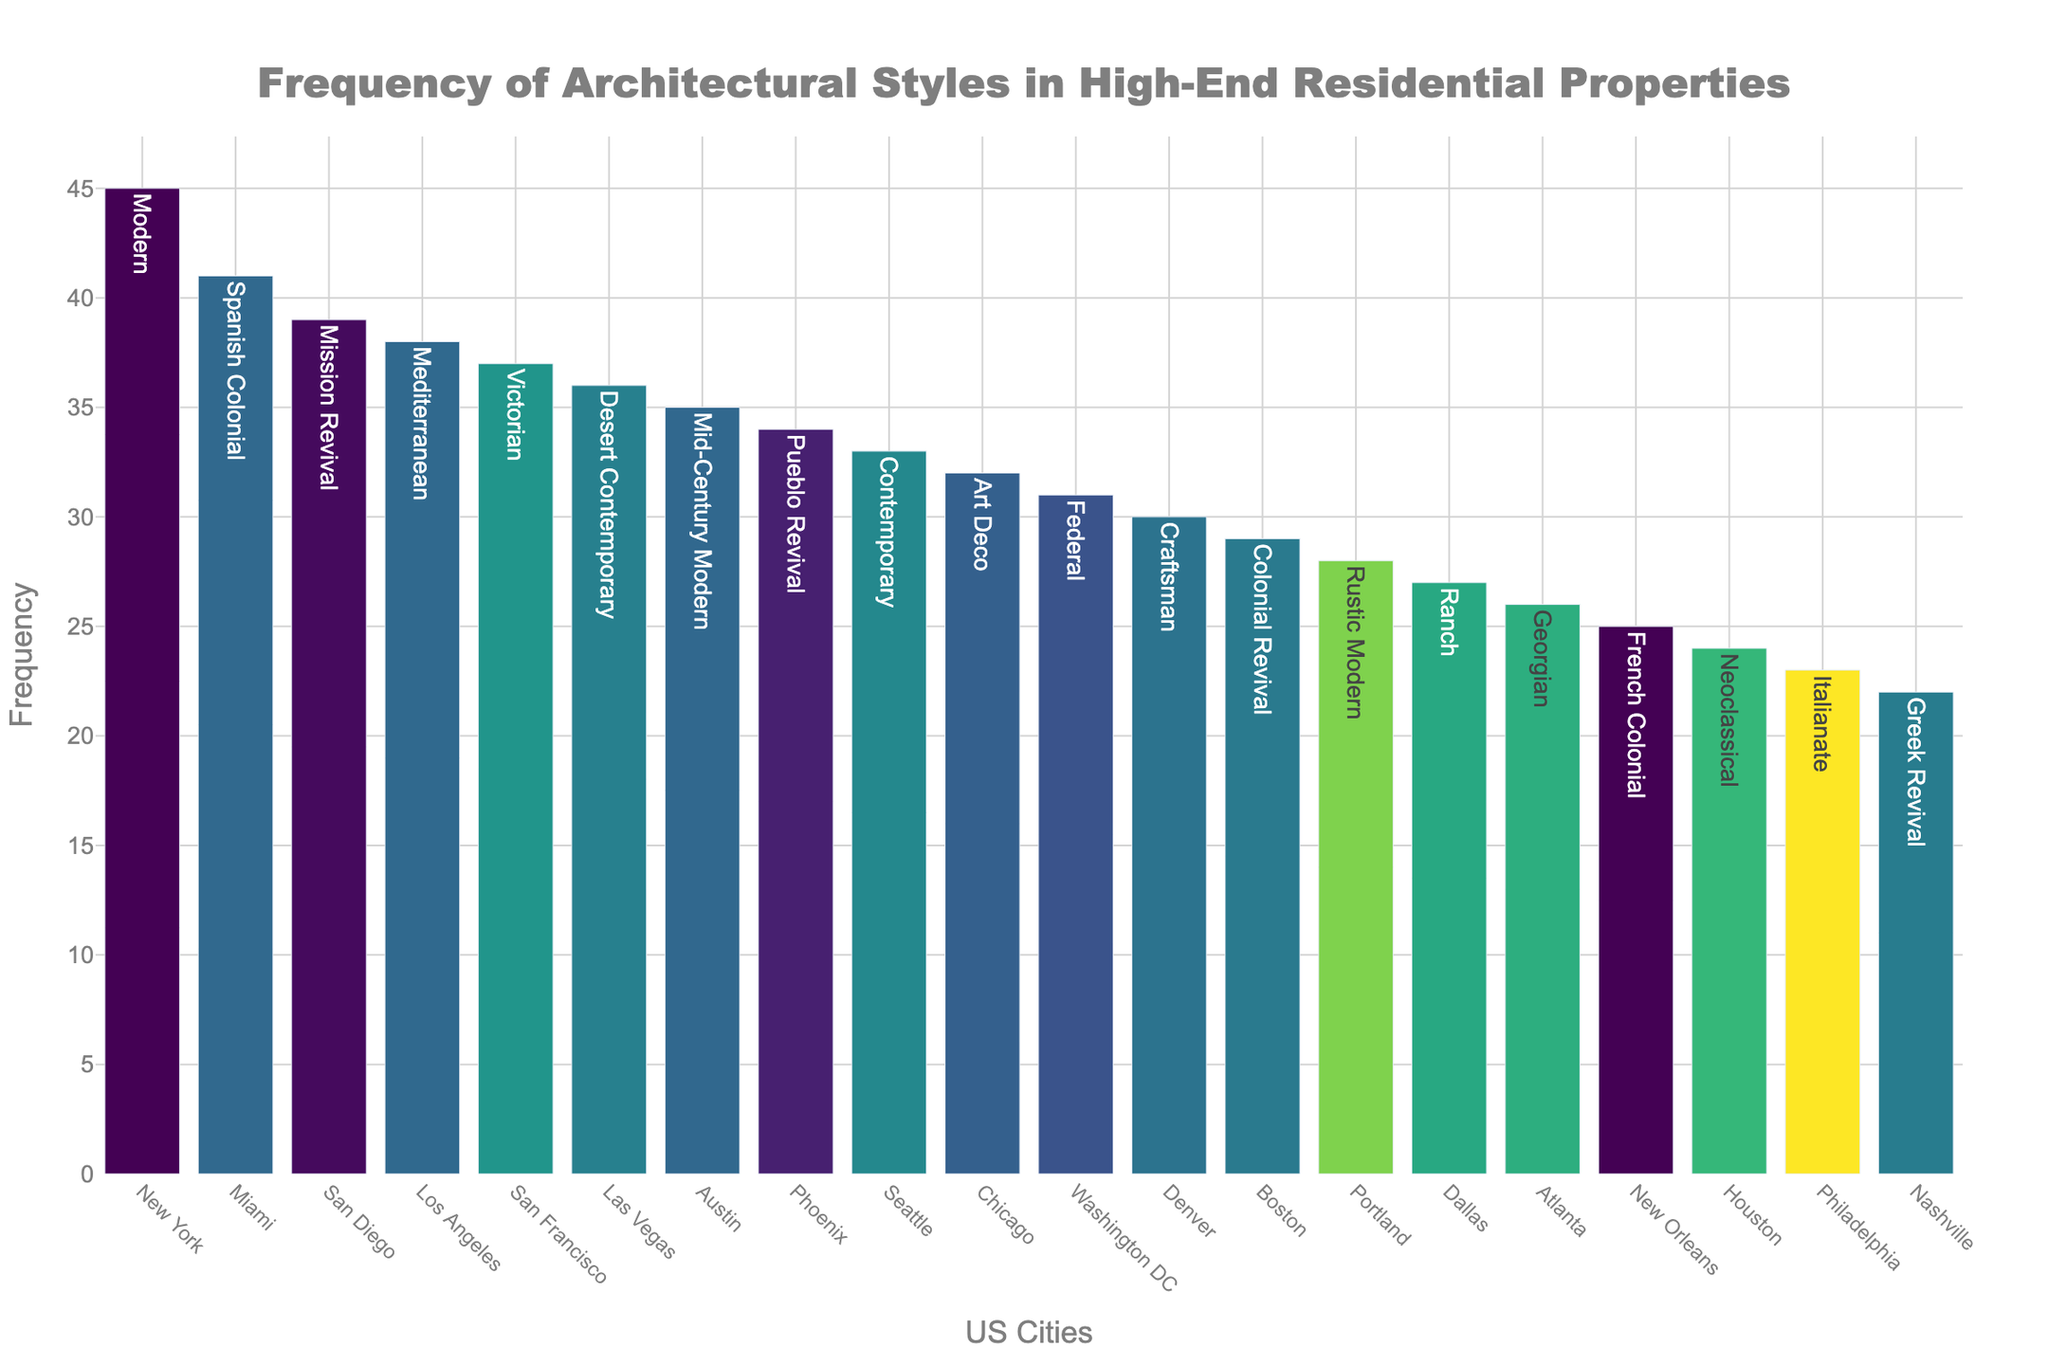What's the title of the plot? The title is written at the top of the plot in a large, bold font that is easy to identify. The text reads "Frequency of Architectural Styles in High-End Residential Properties".
Answer: Frequency of Architectural Styles in High-End Residential Properties What is the y-axis labeled as? The label of the y-axis is found on the vertical line to the left of the plot area. It shows "Frequency".
Answer: Frequency Which city has the highest frequency of a particular architectural style? Look at the tallest bar in the plot. Hovering over or viewing the bar, you can see that New York has the highest frequency with 45 occurrences of the Modern style.
Answer: New York Which city has the lowest frequency of a particular architectural style? Look for the shortest bar in the plot. Hovering over or viewing the bar, you can see that Nashville has the lowest frequency with 22 occurrences of the Greek Revival style.
Answer: Nashville How many cities have a frequency of architectural styles that are above 30? Count the number of bars that have their height above the value of 30 on the y-axis. Those cities are New York, Los Angeles, Miami, San Francisco, Seattle, Austin, Las Vegas, Phoenix, and San Diego. There are nine cities in total.
Answer: 9 What is the combined frequency of the styles in Chicago and Boston? The bar for Chicago shows a frequency of 32 and Boston shows 29. Adding them gives 32 + 29 = 61.
Answer: 61 Which architectural style is the most common in Los Angeles? Hovering over the bar representing Los Angeles will reveal that the most common architectural style there is Mediterranean with a frequency of 38.
Answer: Mediterranean What is the difference in frequency between San Diego and Philadelphia? The frequency for San Diego is shown as 39 and Philadelphia as 23. The difference is calculated as 39 - 23 = 16.
Answer: 16 Are there more cities with frequencies above or below 30? Count the number of bars above and below the value of 30 on the y-axis. Nine cities have frequencies above 30, while eleven cities have frequencies below 30. Therefore, more cities have frequencies below 30.
Answer: Below 30 What architectural style is most common in Phoenix? Hover over or view the bar for Phoenix to see the style listed. The most common architectural style there is Pueblo Revival with a frequency of 34.
Answer: Pueblo Revival 